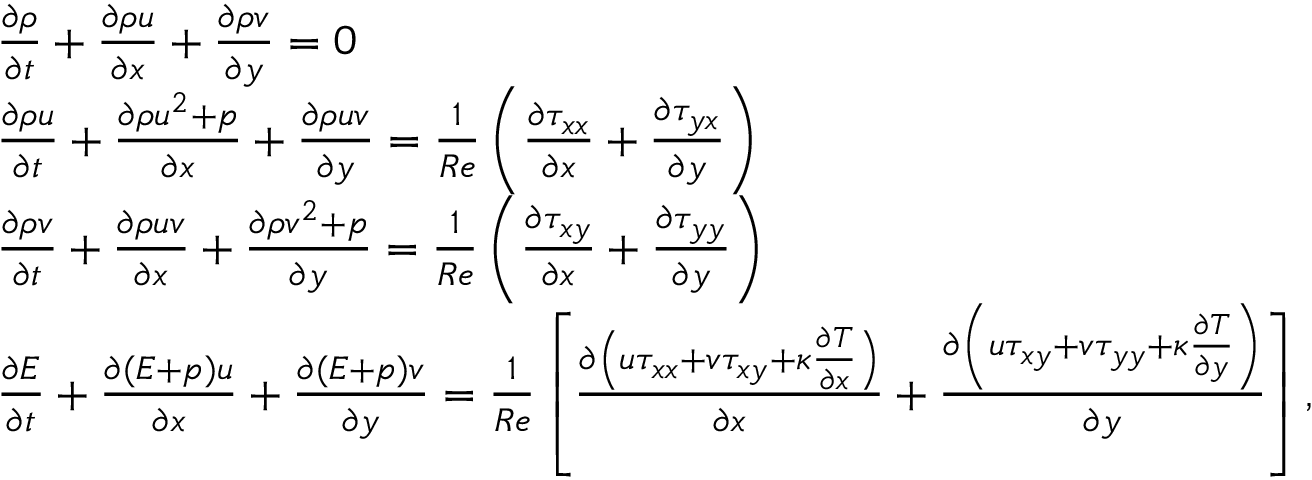<formula> <loc_0><loc_0><loc_500><loc_500>\begin{array} { r } { \begin{array} { r l } & { \frac { \partial { \rho } } { \partial { t } } + \frac { \partial { \rho } { u } } { \partial { x } } + \frac { \partial { \rho } { v } } { \partial { y } } = 0 } \\ & { \frac { \partial { \rho } { u } } { \partial { t } } + \frac { \partial { \rho } { u } ^ { 2 } + { p } } { \partial { x } } + \frac { \partial { \rho } { u } { v } } { \partial { y } } = \frac { 1 } { R e } \left ( \frac { \partial { \tau } _ { x x } } { \partial { x } } + \frac { \partial { \tau } _ { y x } } { \partial { y } } \right ) } \\ & { \frac { \partial { \rho } { v } } { \partial { t } } + \frac { \partial { \rho } { u } { v } } { \partial { x } } + \frac { \partial { \rho } { v } ^ { 2 } + { p } } { \partial { y } } = \frac { 1 } { R e } \left ( \frac { \partial { \tau } _ { x y } } { \partial { x } } + \frac { \partial { \tau } _ { y y } } { \partial { y } } \right ) } \\ & { \frac { \partial { E } } { \partial { t } } + \frac { \partial ( { E } + { p } ) { u } } { \partial { x } } + \frac { \partial ( { E } + { p } ) { v } } { \partial { y } } = \frac { 1 } { R e } \left [ \frac { \partial \left ( { u } { \tau } _ { x x } + { v } { \tau } _ { x y } + { \kappa } \frac { \partial { T } } { \partial { x } } \right ) } { \partial { x } } + \frac { \partial \left ( { u } { \tau } _ { x y } + { v } { \tau } _ { y y } + { \kappa } \frac { \partial { T } } { \partial { y } } \right ) } { \partial { y } } \right ] , } \end{array} } \end{array}</formula> 